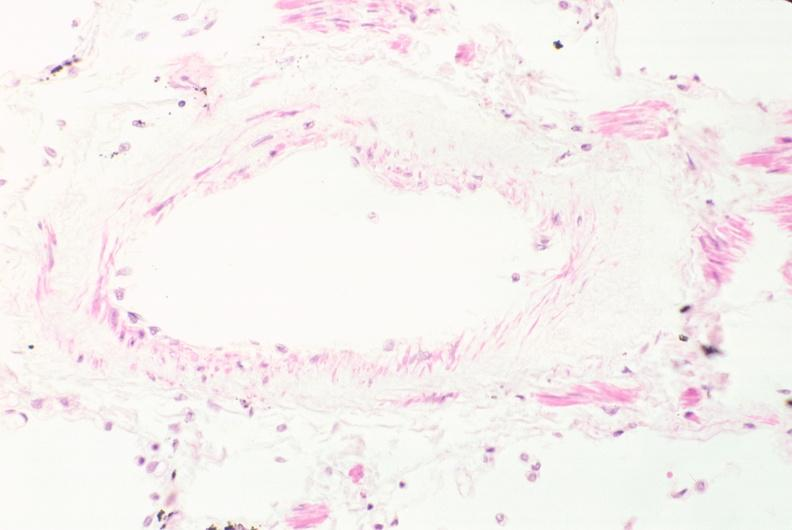does this image show lung, phlebosclerosis?
Answer the question using a single word or phrase. Yes 